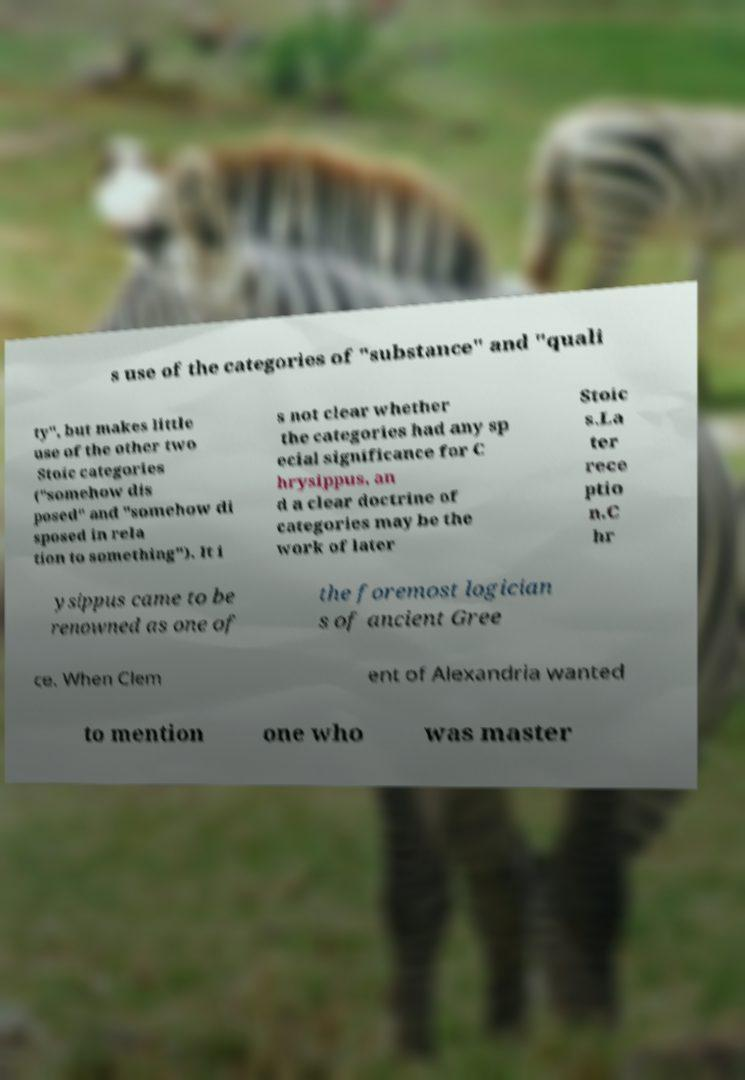I need the written content from this picture converted into text. Can you do that? s use of the categories of "substance" and "quali ty", but makes little use of the other two Stoic categories ("somehow dis posed" and "somehow di sposed in rela tion to something"). It i s not clear whether the categories had any sp ecial significance for C hrysippus, an d a clear doctrine of categories may be the work of later Stoic s.La ter rece ptio n.C hr ysippus came to be renowned as one of the foremost logician s of ancient Gree ce. When Clem ent of Alexandria wanted to mention one who was master 